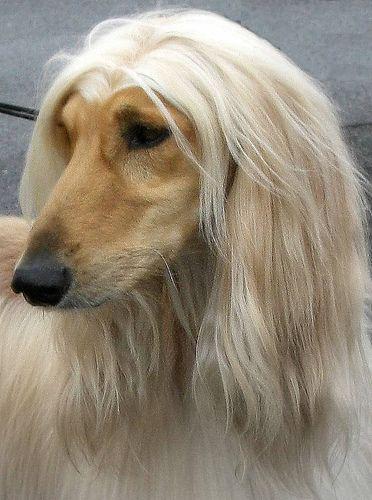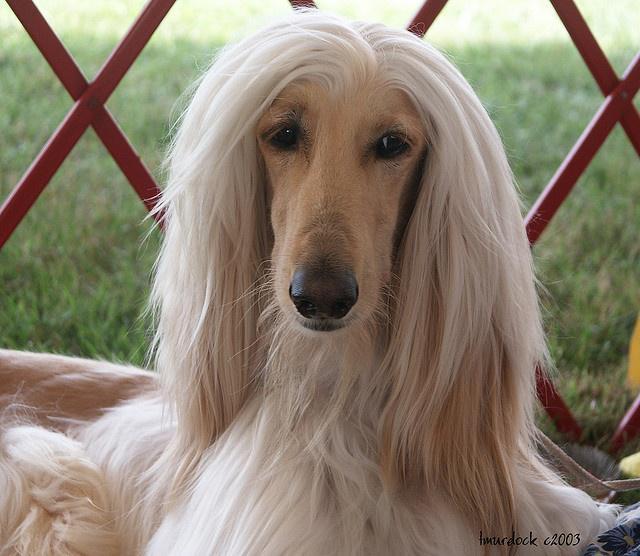The first image is the image on the left, the second image is the image on the right. Given the left and right images, does the statement "A dog is wearing something around its neck." hold true? Answer yes or no. No. The first image is the image on the left, the second image is the image on the right. Given the left and right images, does the statement "The dog on the left has its muzzle pointing slightly rightward, and the dog on the right has a darker muzzle that the rest of its fur or the dog on the left." hold true? Answer yes or no. No. 